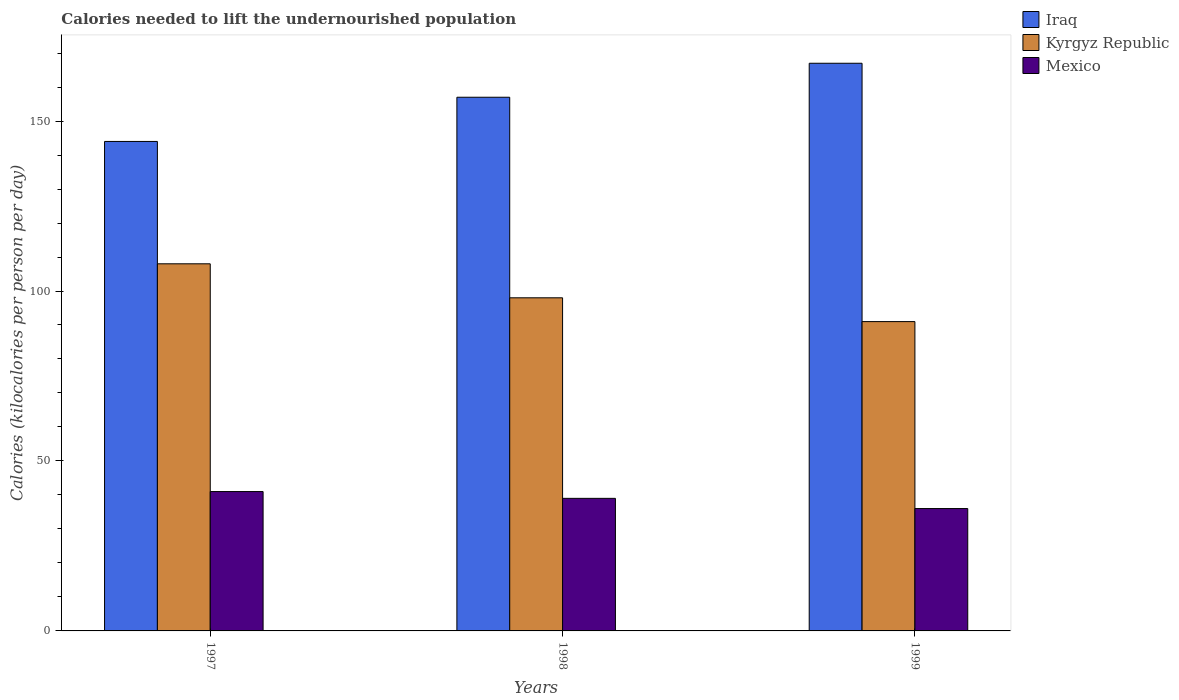How many different coloured bars are there?
Ensure brevity in your answer.  3. How many groups of bars are there?
Offer a very short reply. 3. Are the number of bars per tick equal to the number of legend labels?
Your answer should be compact. Yes. What is the label of the 3rd group of bars from the left?
Make the answer very short. 1999. What is the total calories needed to lift the undernourished population in Kyrgyz Republic in 1997?
Your response must be concise. 108. Across all years, what is the maximum total calories needed to lift the undernourished population in Mexico?
Offer a very short reply. 41. Across all years, what is the minimum total calories needed to lift the undernourished population in Mexico?
Offer a terse response. 36. In which year was the total calories needed to lift the undernourished population in Kyrgyz Republic minimum?
Provide a succinct answer. 1999. What is the total total calories needed to lift the undernourished population in Kyrgyz Republic in the graph?
Your answer should be very brief. 297. What is the difference between the total calories needed to lift the undernourished population in Iraq in 1998 and that in 1999?
Your response must be concise. -10. What is the difference between the total calories needed to lift the undernourished population in Kyrgyz Republic in 1998 and the total calories needed to lift the undernourished population in Mexico in 1997?
Make the answer very short. 57. What is the average total calories needed to lift the undernourished population in Kyrgyz Republic per year?
Provide a succinct answer. 99. In the year 1997, what is the difference between the total calories needed to lift the undernourished population in Kyrgyz Republic and total calories needed to lift the undernourished population in Iraq?
Give a very brief answer. -36. What is the ratio of the total calories needed to lift the undernourished population in Kyrgyz Republic in 1998 to that in 1999?
Offer a terse response. 1.08. What is the difference between the highest and the second highest total calories needed to lift the undernourished population in Iraq?
Your response must be concise. 10. What is the difference between the highest and the lowest total calories needed to lift the undernourished population in Iraq?
Provide a short and direct response. 23. In how many years, is the total calories needed to lift the undernourished population in Mexico greater than the average total calories needed to lift the undernourished population in Mexico taken over all years?
Provide a succinct answer. 2. Is the sum of the total calories needed to lift the undernourished population in Kyrgyz Republic in 1997 and 1998 greater than the maximum total calories needed to lift the undernourished population in Mexico across all years?
Keep it short and to the point. Yes. What does the 2nd bar from the left in 1997 represents?
Give a very brief answer. Kyrgyz Republic. What does the 2nd bar from the right in 1999 represents?
Give a very brief answer. Kyrgyz Republic. Is it the case that in every year, the sum of the total calories needed to lift the undernourished population in Iraq and total calories needed to lift the undernourished population in Kyrgyz Republic is greater than the total calories needed to lift the undernourished population in Mexico?
Your answer should be compact. Yes. How many bars are there?
Your answer should be very brief. 9. Are all the bars in the graph horizontal?
Keep it short and to the point. No. How many years are there in the graph?
Make the answer very short. 3. What is the difference between two consecutive major ticks on the Y-axis?
Provide a short and direct response. 50. Where does the legend appear in the graph?
Offer a terse response. Top right. What is the title of the graph?
Give a very brief answer. Calories needed to lift the undernourished population. What is the label or title of the Y-axis?
Ensure brevity in your answer.  Calories (kilocalories per person per day). What is the Calories (kilocalories per person per day) in Iraq in 1997?
Your answer should be very brief. 144. What is the Calories (kilocalories per person per day) in Kyrgyz Republic in 1997?
Your answer should be very brief. 108. What is the Calories (kilocalories per person per day) of Mexico in 1997?
Your response must be concise. 41. What is the Calories (kilocalories per person per day) of Iraq in 1998?
Offer a terse response. 157. What is the Calories (kilocalories per person per day) in Kyrgyz Republic in 1998?
Ensure brevity in your answer.  98. What is the Calories (kilocalories per person per day) of Iraq in 1999?
Offer a very short reply. 167. What is the Calories (kilocalories per person per day) in Kyrgyz Republic in 1999?
Keep it short and to the point. 91. Across all years, what is the maximum Calories (kilocalories per person per day) in Iraq?
Provide a short and direct response. 167. Across all years, what is the maximum Calories (kilocalories per person per day) of Kyrgyz Republic?
Provide a short and direct response. 108. Across all years, what is the minimum Calories (kilocalories per person per day) of Iraq?
Offer a very short reply. 144. Across all years, what is the minimum Calories (kilocalories per person per day) in Kyrgyz Republic?
Your answer should be compact. 91. What is the total Calories (kilocalories per person per day) in Iraq in the graph?
Your answer should be very brief. 468. What is the total Calories (kilocalories per person per day) of Kyrgyz Republic in the graph?
Give a very brief answer. 297. What is the total Calories (kilocalories per person per day) of Mexico in the graph?
Your answer should be compact. 116. What is the difference between the Calories (kilocalories per person per day) in Mexico in 1997 and that in 1998?
Your response must be concise. 2. What is the difference between the Calories (kilocalories per person per day) in Iraq in 1997 and the Calories (kilocalories per person per day) in Mexico in 1998?
Keep it short and to the point. 105. What is the difference between the Calories (kilocalories per person per day) in Iraq in 1997 and the Calories (kilocalories per person per day) in Kyrgyz Republic in 1999?
Give a very brief answer. 53. What is the difference between the Calories (kilocalories per person per day) of Iraq in 1997 and the Calories (kilocalories per person per day) of Mexico in 1999?
Give a very brief answer. 108. What is the difference between the Calories (kilocalories per person per day) of Kyrgyz Republic in 1997 and the Calories (kilocalories per person per day) of Mexico in 1999?
Offer a very short reply. 72. What is the difference between the Calories (kilocalories per person per day) of Iraq in 1998 and the Calories (kilocalories per person per day) of Mexico in 1999?
Provide a short and direct response. 121. What is the difference between the Calories (kilocalories per person per day) in Kyrgyz Republic in 1998 and the Calories (kilocalories per person per day) in Mexico in 1999?
Your answer should be compact. 62. What is the average Calories (kilocalories per person per day) in Iraq per year?
Offer a terse response. 156. What is the average Calories (kilocalories per person per day) of Mexico per year?
Give a very brief answer. 38.67. In the year 1997, what is the difference between the Calories (kilocalories per person per day) of Iraq and Calories (kilocalories per person per day) of Mexico?
Offer a very short reply. 103. In the year 1997, what is the difference between the Calories (kilocalories per person per day) in Kyrgyz Republic and Calories (kilocalories per person per day) in Mexico?
Offer a very short reply. 67. In the year 1998, what is the difference between the Calories (kilocalories per person per day) of Iraq and Calories (kilocalories per person per day) of Kyrgyz Republic?
Provide a succinct answer. 59. In the year 1998, what is the difference between the Calories (kilocalories per person per day) in Iraq and Calories (kilocalories per person per day) in Mexico?
Your response must be concise. 118. In the year 1999, what is the difference between the Calories (kilocalories per person per day) in Iraq and Calories (kilocalories per person per day) in Kyrgyz Republic?
Your answer should be compact. 76. In the year 1999, what is the difference between the Calories (kilocalories per person per day) in Iraq and Calories (kilocalories per person per day) in Mexico?
Provide a succinct answer. 131. In the year 1999, what is the difference between the Calories (kilocalories per person per day) in Kyrgyz Republic and Calories (kilocalories per person per day) in Mexico?
Your response must be concise. 55. What is the ratio of the Calories (kilocalories per person per day) of Iraq in 1997 to that in 1998?
Keep it short and to the point. 0.92. What is the ratio of the Calories (kilocalories per person per day) of Kyrgyz Republic in 1997 to that in 1998?
Offer a terse response. 1.1. What is the ratio of the Calories (kilocalories per person per day) in Mexico in 1997 to that in 1998?
Offer a very short reply. 1.05. What is the ratio of the Calories (kilocalories per person per day) of Iraq in 1997 to that in 1999?
Offer a terse response. 0.86. What is the ratio of the Calories (kilocalories per person per day) of Kyrgyz Republic in 1997 to that in 1999?
Your answer should be very brief. 1.19. What is the ratio of the Calories (kilocalories per person per day) in Mexico in 1997 to that in 1999?
Make the answer very short. 1.14. What is the ratio of the Calories (kilocalories per person per day) in Iraq in 1998 to that in 1999?
Provide a short and direct response. 0.94. What is the ratio of the Calories (kilocalories per person per day) in Kyrgyz Republic in 1998 to that in 1999?
Offer a very short reply. 1.08. 